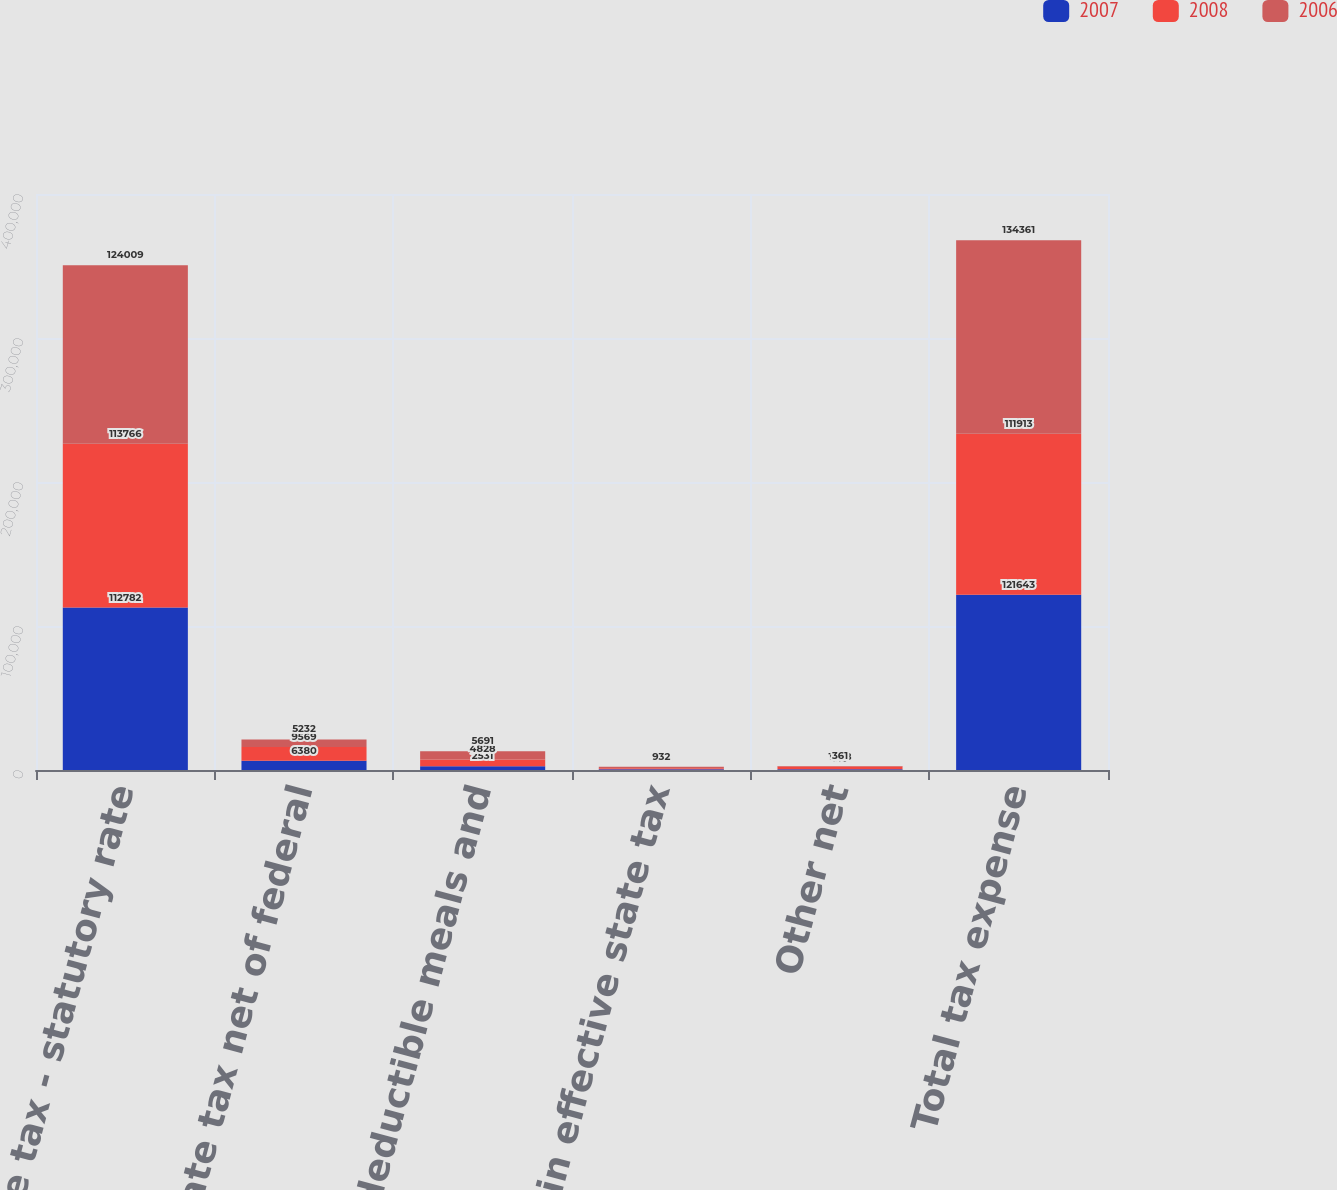Convert chart to OTSL. <chart><loc_0><loc_0><loc_500><loc_500><stacked_bar_chart><ecel><fcel>Income tax - statutory rate<fcel>State tax net of federal<fcel>Nondeductible meals and<fcel>Change in effective state tax<fcel>Other net<fcel>Total tax expense<nl><fcel>2007<fcel>112782<fcel>6380<fcel>2531<fcel>569<fcel>519<fcel>121643<nl><fcel>2008<fcel>113766<fcel>9569<fcel>4828<fcel>714<fcel>1858<fcel>111913<nl><fcel>2006<fcel>124009<fcel>5232<fcel>5691<fcel>932<fcel>361<fcel>134361<nl></chart> 